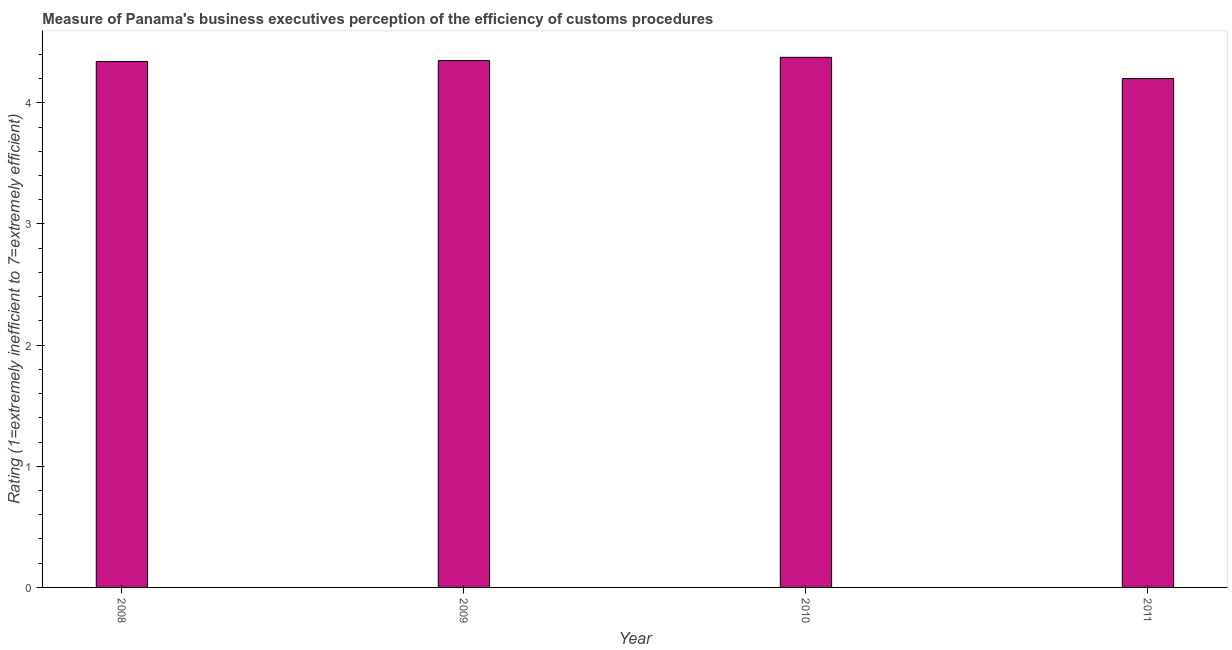What is the title of the graph?
Your response must be concise. Measure of Panama's business executives perception of the efficiency of customs procedures. What is the label or title of the Y-axis?
Provide a succinct answer. Rating (1=extremely inefficient to 7=extremely efficient). What is the rating measuring burden of customs procedure in 2011?
Make the answer very short. 4.2. Across all years, what is the maximum rating measuring burden of customs procedure?
Your answer should be very brief. 4.38. In which year was the rating measuring burden of customs procedure maximum?
Give a very brief answer. 2010. In which year was the rating measuring burden of customs procedure minimum?
Provide a succinct answer. 2011. What is the sum of the rating measuring burden of customs procedure?
Your answer should be compact. 17.26. What is the difference between the rating measuring burden of customs procedure in 2008 and 2010?
Give a very brief answer. -0.03. What is the average rating measuring burden of customs procedure per year?
Offer a very short reply. 4.32. What is the median rating measuring burden of customs procedure?
Your answer should be very brief. 4.34. What is the ratio of the rating measuring burden of customs procedure in 2008 to that in 2011?
Your response must be concise. 1.03. Is the difference between the rating measuring burden of customs procedure in 2008 and 2011 greater than the difference between any two years?
Your answer should be very brief. No. What is the difference between the highest and the second highest rating measuring burden of customs procedure?
Provide a short and direct response. 0.03. What is the difference between the highest and the lowest rating measuring burden of customs procedure?
Keep it short and to the point. 0.18. In how many years, is the rating measuring burden of customs procedure greater than the average rating measuring burden of customs procedure taken over all years?
Offer a very short reply. 3. Are all the bars in the graph horizontal?
Ensure brevity in your answer.  No. What is the Rating (1=extremely inefficient to 7=extremely efficient) in 2008?
Provide a succinct answer. 4.34. What is the Rating (1=extremely inefficient to 7=extremely efficient) in 2009?
Your answer should be compact. 4.35. What is the Rating (1=extremely inefficient to 7=extremely efficient) of 2010?
Ensure brevity in your answer.  4.38. What is the difference between the Rating (1=extremely inefficient to 7=extremely efficient) in 2008 and 2009?
Provide a short and direct response. -0.01. What is the difference between the Rating (1=extremely inefficient to 7=extremely efficient) in 2008 and 2010?
Your answer should be very brief. -0.03. What is the difference between the Rating (1=extremely inefficient to 7=extremely efficient) in 2008 and 2011?
Your answer should be compact. 0.14. What is the difference between the Rating (1=extremely inefficient to 7=extremely efficient) in 2009 and 2010?
Offer a very short reply. -0.03. What is the difference between the Rating (1=extremely inefficient to 7=extremely efficient) in 2009 and 2011?
Provide a short and direct response. 0.15. What is the difference between the Rating (1=extremely inefficient to 7=extremely efficient) in 2010 and 2011?
Ensure brevity in your answer.  0.18. What is the ratio of the Rating (1=extremely inefficient to 7=extremely efficient) in 2008 to that in 2009?
Offer a terse response. 1. What is the ratio of the Rating (1=extremely inefficient to 7=extremely efficient) in 2008 to that in 2011?
Offer a very short reply. 1.03. What is the ratio of the Rating (1=extremely inefficient to 7=extremely efficient) in 2009 to that in 2010?
Provide a short and direct response. 0.99. What is the ratio of the Rating (1=extremely inefficient to 7=extremely efficient) in 2009 to that in 2011?
Provide a succinct answer. 1.03. What is the ratio of the Rating (1=extremely inefficient to 7=extremely efficient) in 2010 to that in 2011?
Make the answer very short. 1.04. 